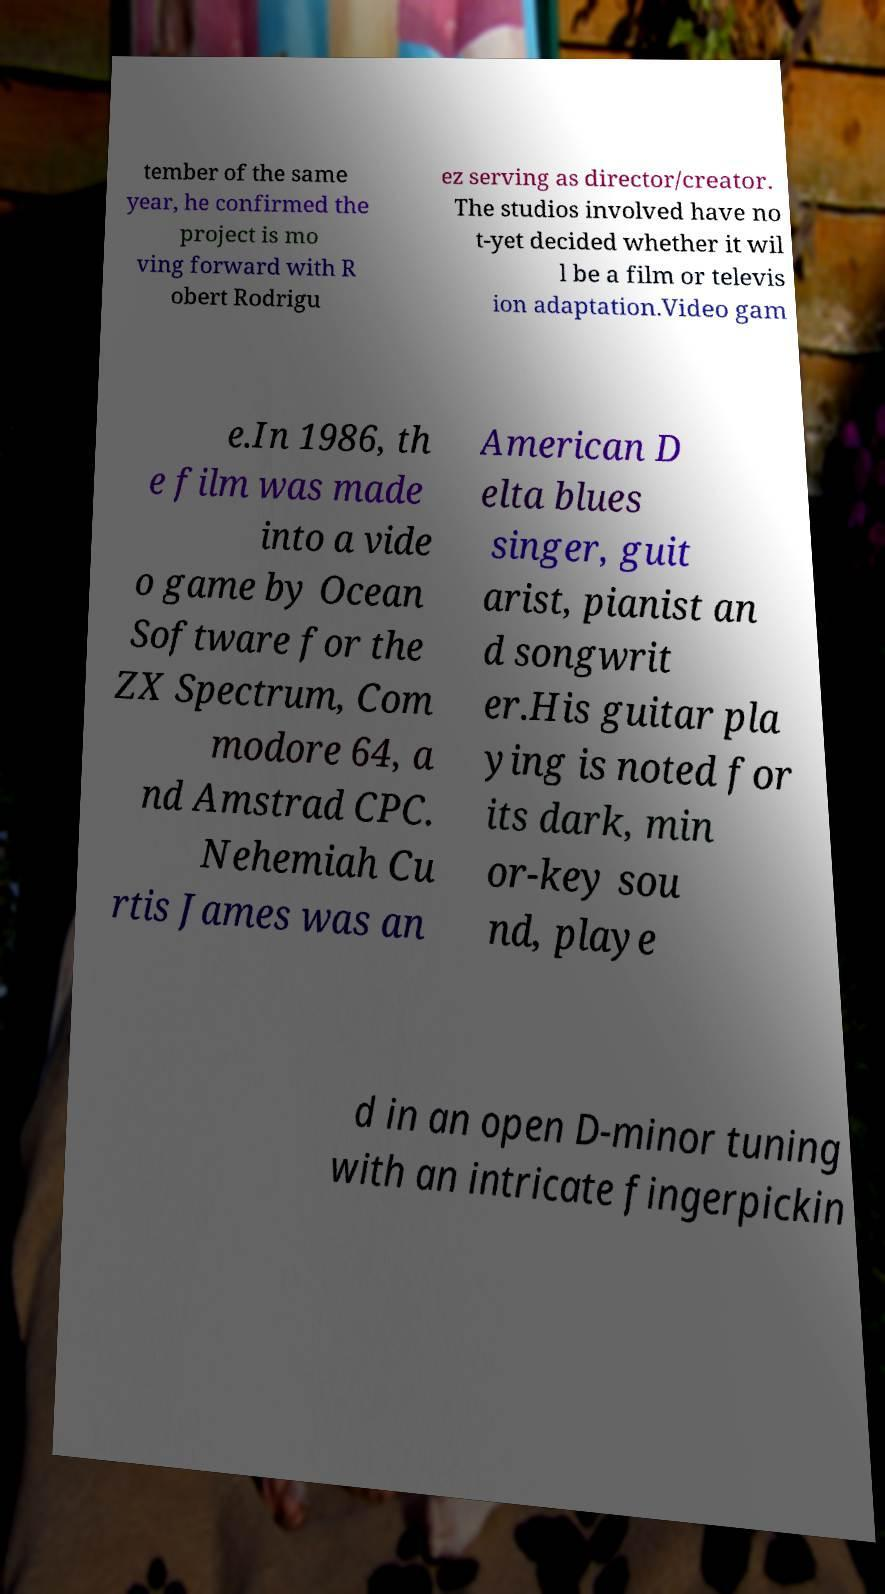Please identify and transcribe the text found in this image. tember of the same year, he confirmed the project is mo ving forward with R obert Rodrigu ez serving as director/creator. The studios involved have no t-yet decided whether it wil l be a film or televis ion adaptation.Video gam e.In 1986, th e film was made into a vide o game by Ocean Software for the ZX Spectrum, Com modore 64, a nd Amstrad CPC. Nehemiah Cu rtis James was an American D elta blues singer, guit arist, pianist an d songwrit er.His guitar pla ying is noted for its dark, min or-key sou nd, playe d in an open D-minor tuning with an intricate fingerpickin 